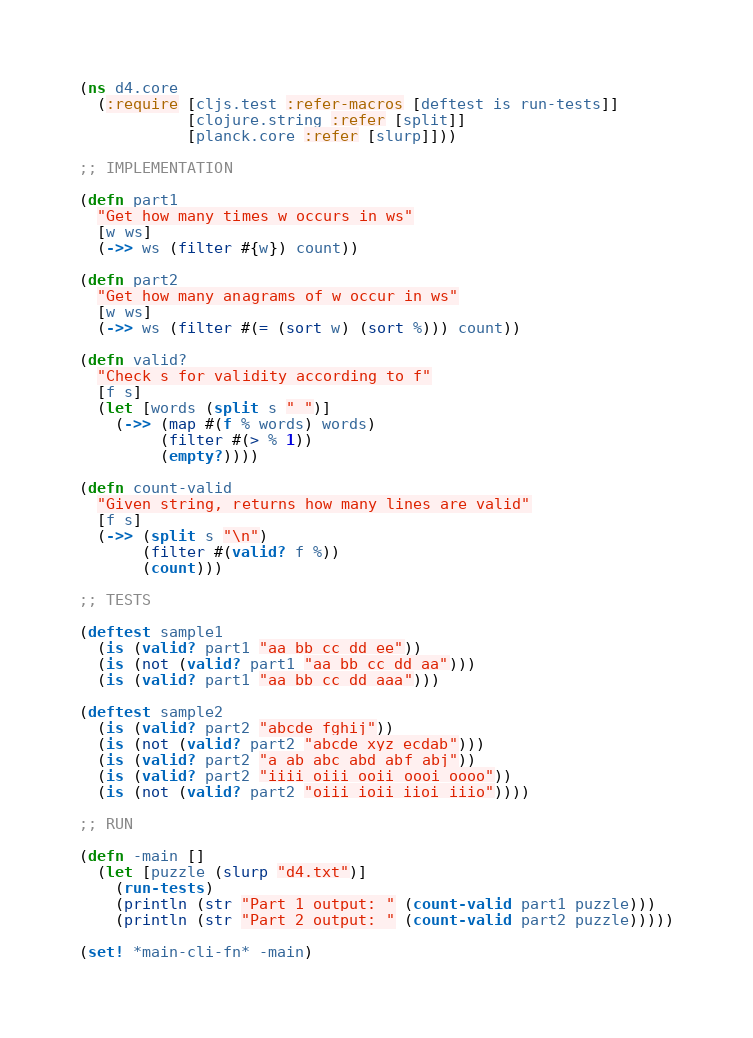<code> <loc_0><loc_0><loc_500><loc_500><_Clojure_>(ns d4.core
  (:require [cljs.test :refer-macros [deftest is run-tests]]
            [clojure.string :refer [split]]
            [planck.core :refer [slurp]]))

;; IMPLEMENTATION

(defn part1
  "Get how many times w occurs in ws"
  [w ws]
  (->> ws (filter #{w}) count))

(defn part2
  "Get how many anagrams of w occur in ws"
  [w ws]
  (->> ws (filter #(= (sort w) (sort %))) count))

(defn valid?
  "Check s for validity according to f"
  [f s]
  (let [words (split s " ")]
    (->> (map #(f % words) words)
         (filter #(> % 1))
         (empty?))))

(defn count-valid
  "Given string, returns how many lines are valid"
  [f s]
  (->> (split s "\n")
       (filter #(valid? f %))
       (count)))

;; TESTS

(deftest sample1
  (is (valid? part1 "aa bb cc dd ee"))
  (is (not (valid? part1 "aa bb cc dd aa")))
  (is (valid? part1 "aa bb cc dd aaa")))

(deftest sample2
  (is (valid? part2 "abcde fghij"))
  (is (not (valid? part2 "abcde xyz ecdab")))
  (is (valid? part2 "a ab abc abd abf abj"))
  (is (valid? part2 "iiii oiii ooii oooi oooo"))
  (is (not (valid? part2 "oiii ioii iioi iiio"))))

;; RUN

(defn -main []
  (let [puzzle (slurp "d4.txt")]
    (run-tests)
    (println (str "Part 1 output: " (count-valid part1 puzzle)))
    (println (str "Part 2 output: " (count-valid part2 puzzle)))))

(set! *main-cli-fn* -main)
</code> 